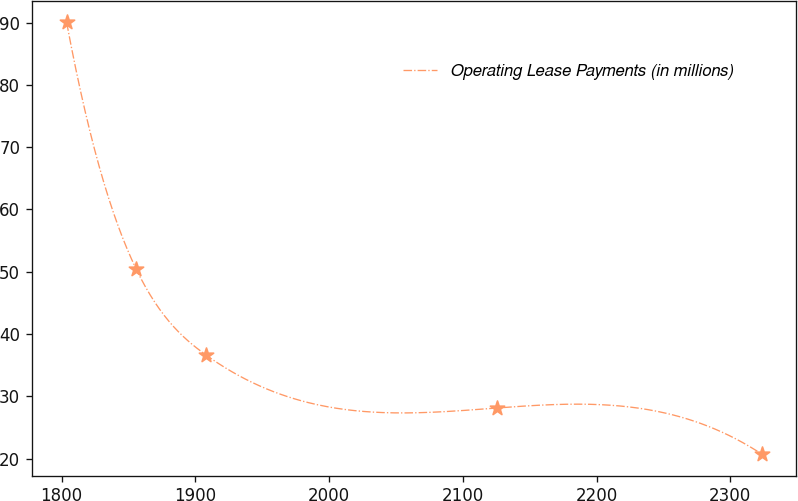Convert chart. <chart><loc_0><loc_0><loc_500><loc_500><line_chart><ecel><fcel>Operating Lease Payments (in millions)<nl><fcel>1803.76<fcel>90.01<nl><fcel>1855.72<fcel>50.45<nl><fcel>1907.68<fcel>36.69<nl><fcel>2125.54<fcel>28.14<nl><fcel>2323.37<fcel>20.76<nl></chart> 